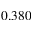<formula> <loc_0><loc_0><loc_500><loc_500>0 . 3 8 0</formula> 